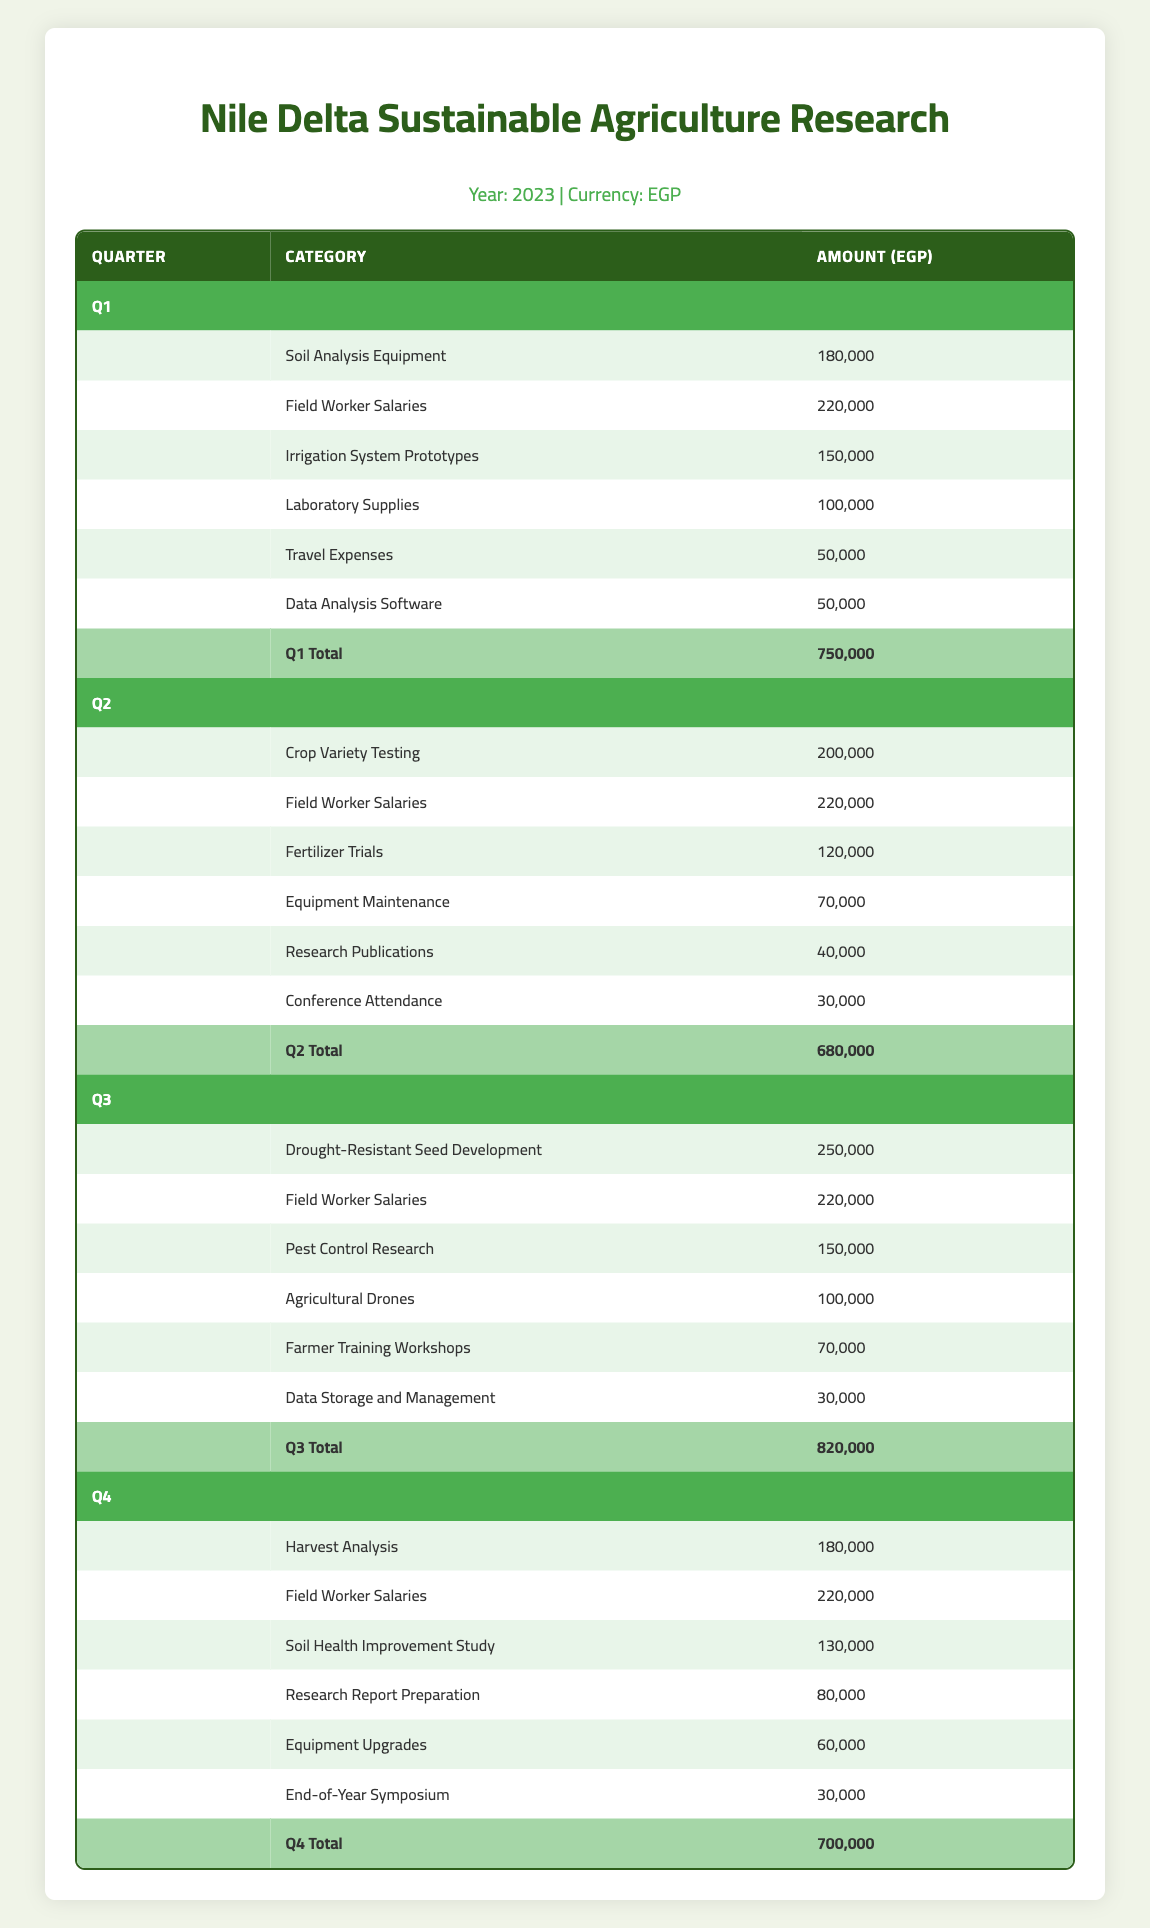What is the total budget allocation for Q3? The total budget allocation for Q3 is stated directly in the table under the Q3 Total row, which shows an amount of 820,000 EGP.
Answer: 820,000 EGP What is the amount allocated for Field Worker Salaries in Q2? The table lists Field Worker Salaries under Q2, where the amount allocated is clearly specified as 220,000 EGP.
Answer: 220,000 EGP Is the amount allocated for Travel Expenses in Q1 greater than the amount allocated for Conference Attendance in Q2? From the table, Travel Expenses in Q1 is 50,000 EGP, and Conference Attendance in Q2 is 30,000 EGP. Since 50,000 is greater than 30,000, the answer is yes.
Answer: Yes What is the total amount allocated for research-related activities (Laboratory Supplies, Research Publications, Research Report Preparation) across all quarters? First, let’s find these specific allocations: Laboratory Supplies in Q1 is 100,000 EGP, Research Publications in Q2 is 40,000 EGP, and Research Report Preparation in Q4 is 80,000 EGP. Summing them gives: 100,000 + 40,000 + 80,000 = 220,000 EGP.
Answer: 220,000 EGP Which quarter has the highest total budget allocation? By comparing the total budgets listed for each quarter, Q3 has the highest total amount of 820,000 EGP, while Q4 has 700,000 EGP, Q2 has 680,000 EGP, and Q1 has 750,000 EGP. Therefore, Q3 has the highest total.
Answer: Q3 